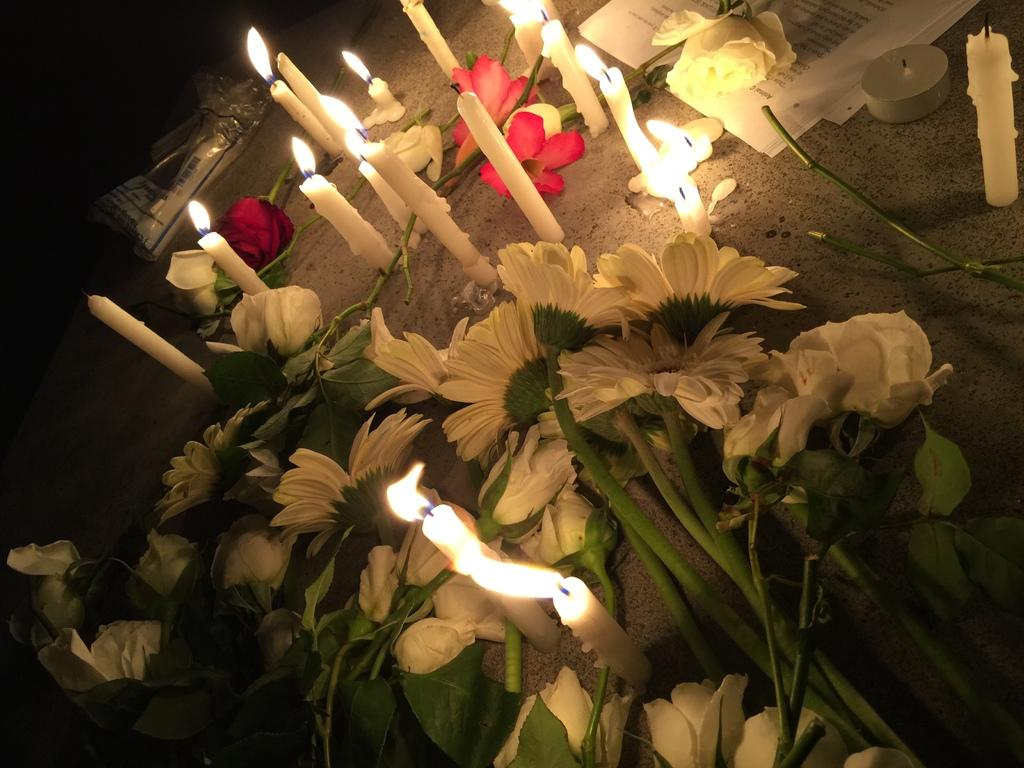What type of flowers can be seen in the image? There are white color flowers in the image. What objects are placed on the ground in the image? There are candles placed on the ground in the image. What other items are present in the image besides flowers and candles? There are white papers in the image. What type of horn is being played by the bear in the image? There are no bears or horns present in the image. 